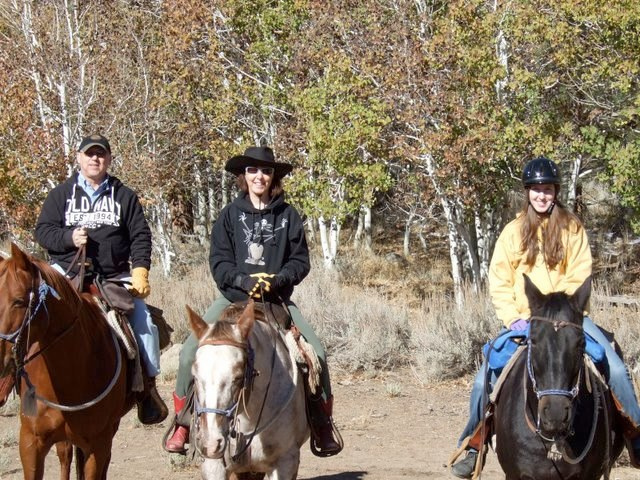What might be the experience level of the riders? Assessing by their attire and posture, the riders have varying levels of experience. The rider in the middle, for example, appears to be confident and comfortable, suggesting a higher level of experience. In contrast, the rider on the right is using a helmet, which may indicate a more cautious or novice rider. However, appearances can be deceiving, and all riders appear to be enjoying their time regardless of their experience level. 